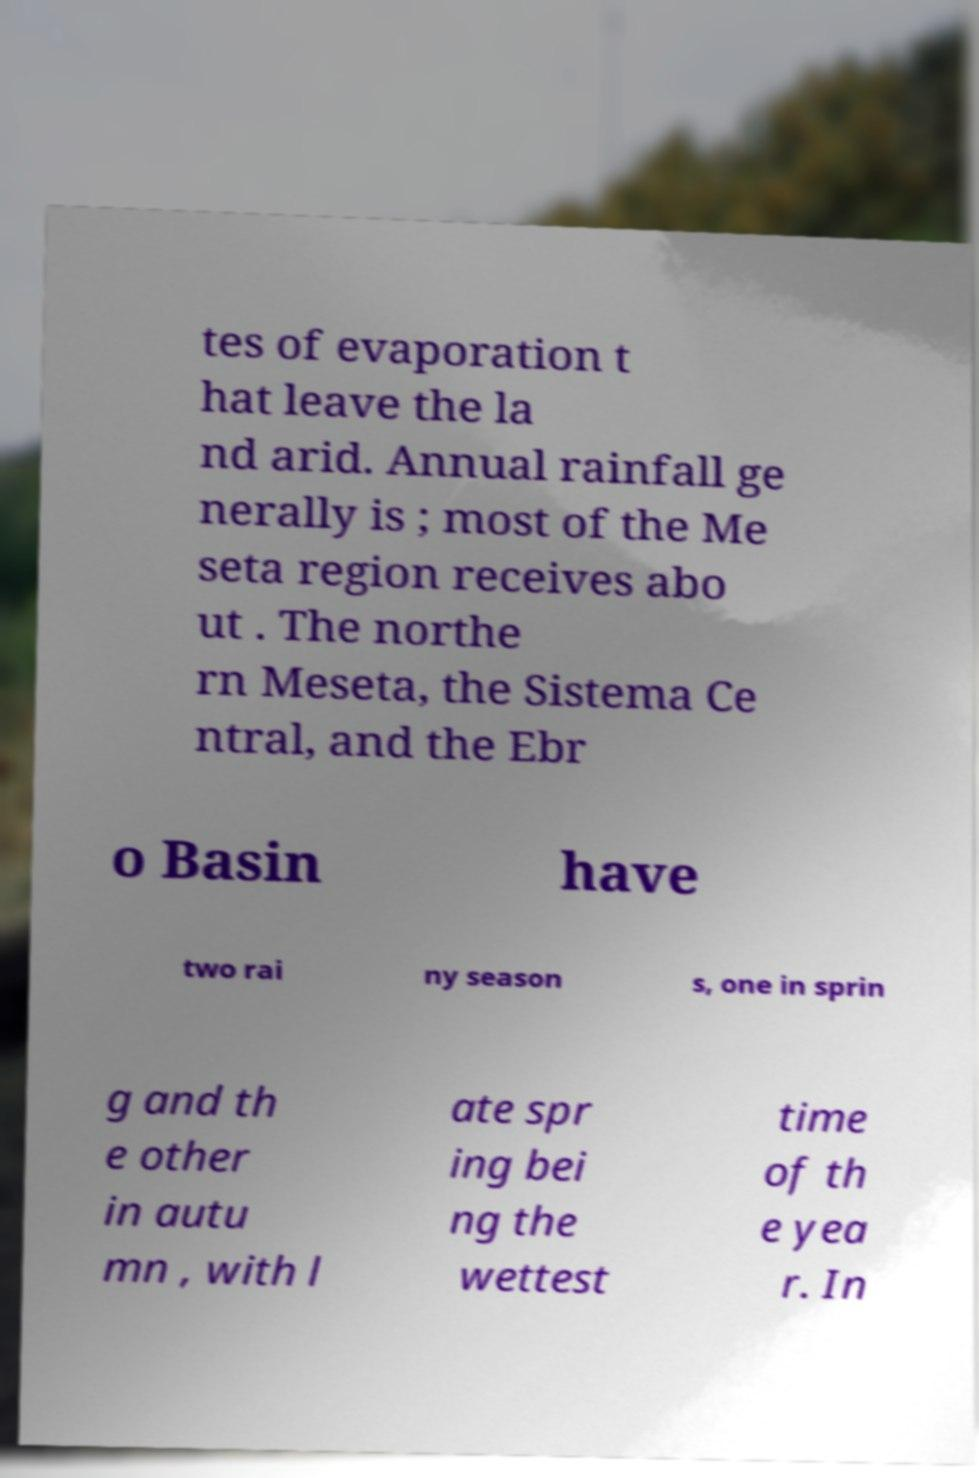Could you extract and type out the text from this image? tes of evaporation t hat leave the la nd arid. Annual rainfall ge nerally is ; most of the Me seta region receives abo ut . The northe rn Meseta, the Sistema Ce ntral, and the Ebr o Basin have two rai ny season s, one in sprin g and th e other in autu mn , with l ate spr ing bei ng the wettest time of th e yea r. In 